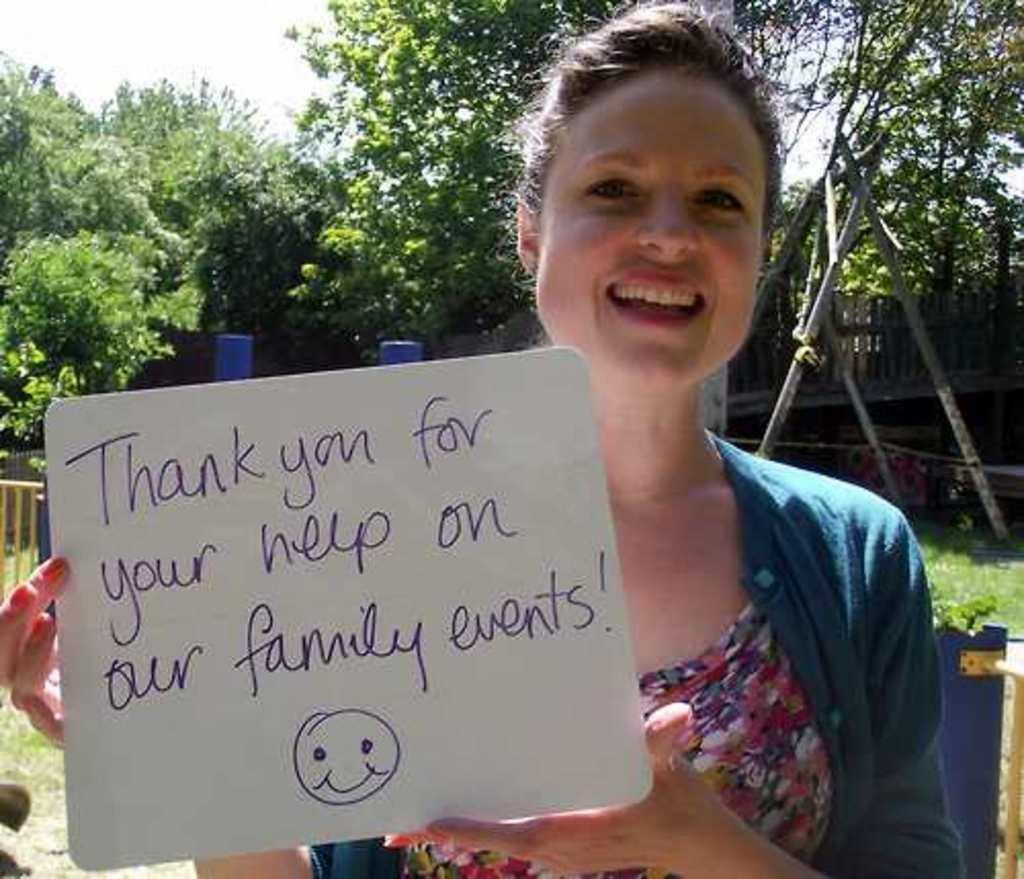What is the woman in the image doing? The woman is standing in the image and holding a board. What can be seen in the background of the image? Trees are visible in the background of the image. What is visible at the top of the image? The sky is at the top of the image. What shape is the ant in the image? There is no ant present in the image. What type of can is visible in the image? There is no can present in the image. 